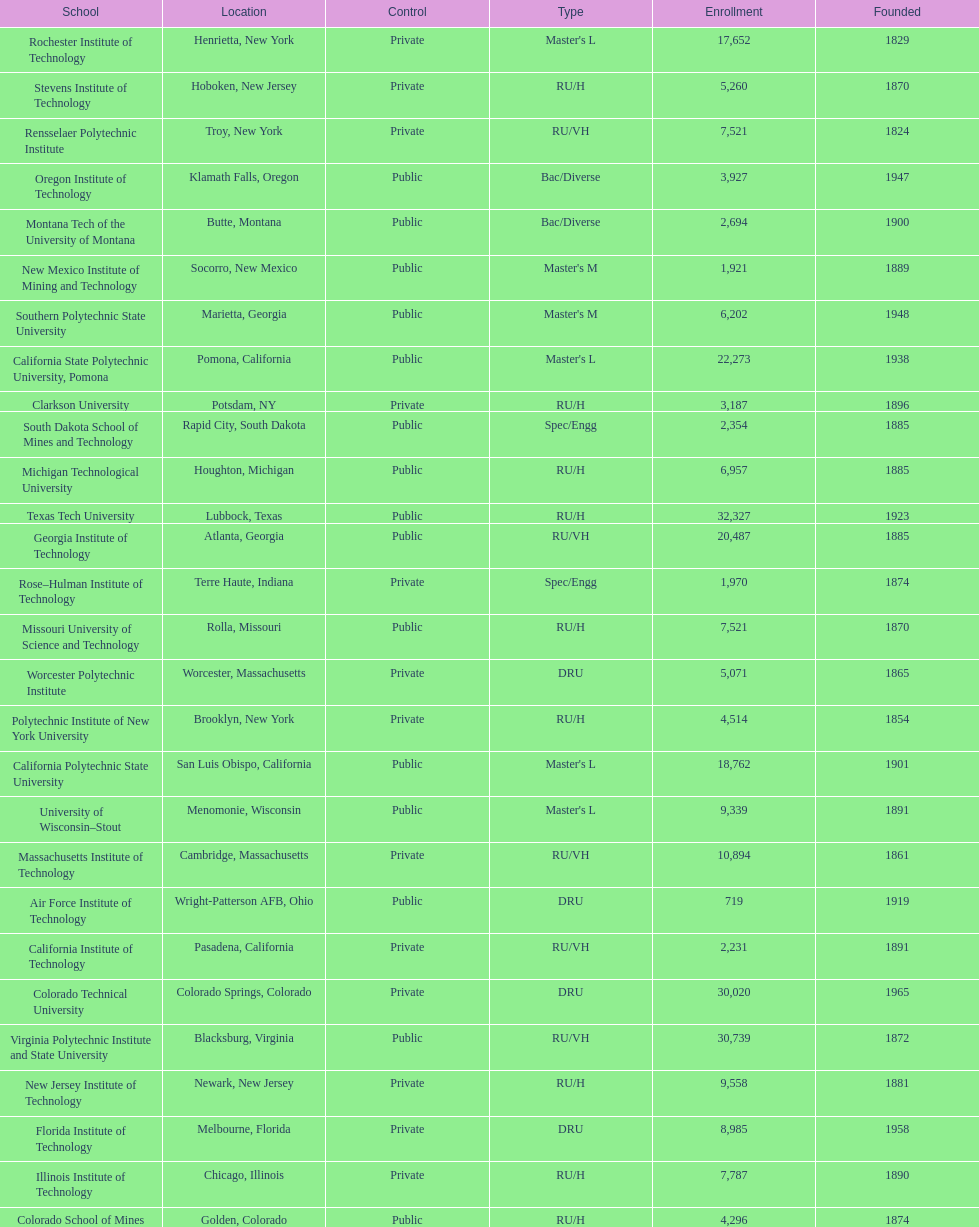What is the number of us technological schools in the state of california? 3. 